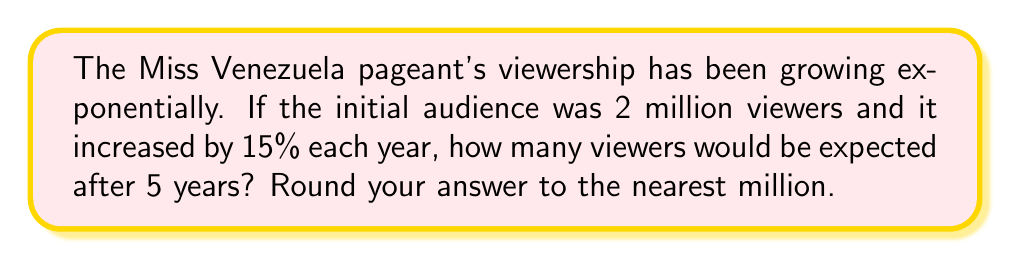What is the answer to this math problem? Let's approach this step-by-step:

1) The initial viewership is 2 million.
2) Each year, the viewership increases by 15%, which means it's multiplied by 1.15.
3) We need to calculate this growth over 5 years.

We can express this mathematically as:

$$ \text{Viewers after 5 years} = 2 \times (1.15)^5 $$

Let's solve this:

$$ \begin{align}
2 \times (1.15)^5 &= 2 \times 2.0113689... \\
&= 4.0227378...
\end{align} $$

Rounding to the nearest million:

$$ 4.0227378... \approx 4 \text{ million} $$
Answer: 4 million viewers 